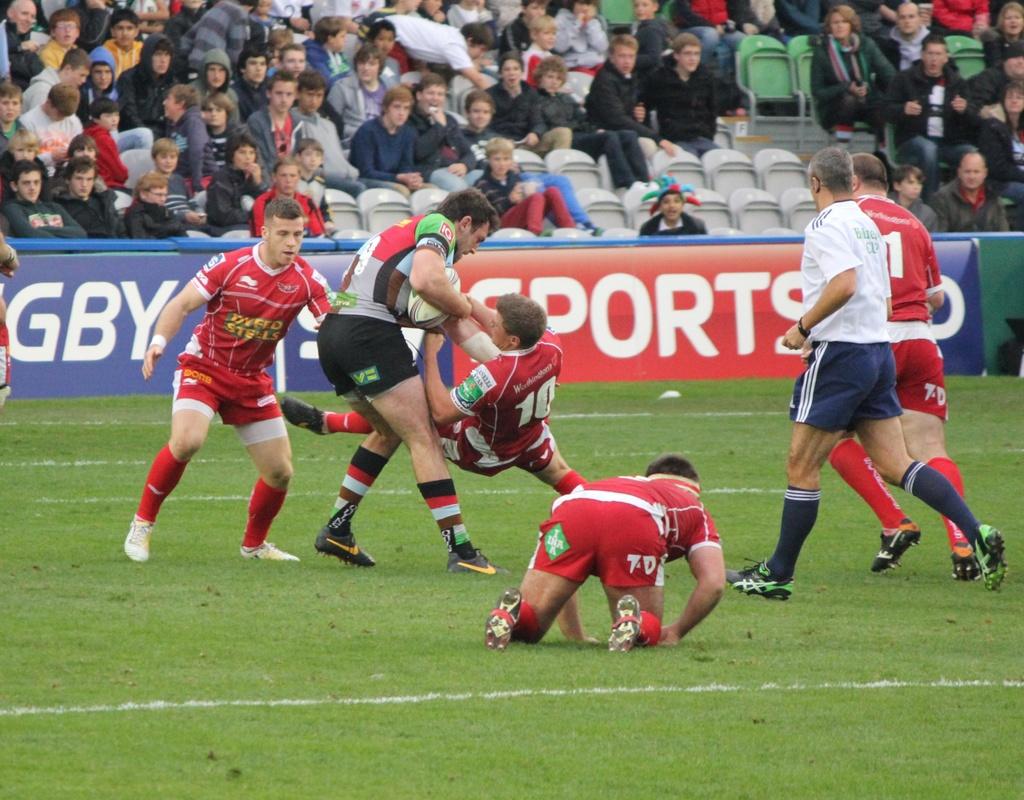What is the number of the player falling down while trying to tackle the man holding the ball?
Give a very brief answer. 10. What is the word in white text on the red banner>?
Offer a terse response. Sports. 